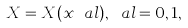Convert formula to latex. <formula><loc_0><loc_0><loc_500><loc_500>X = X ( x ^ { \ } a l ) , \ a l = 0 , 1 ,</formula> 